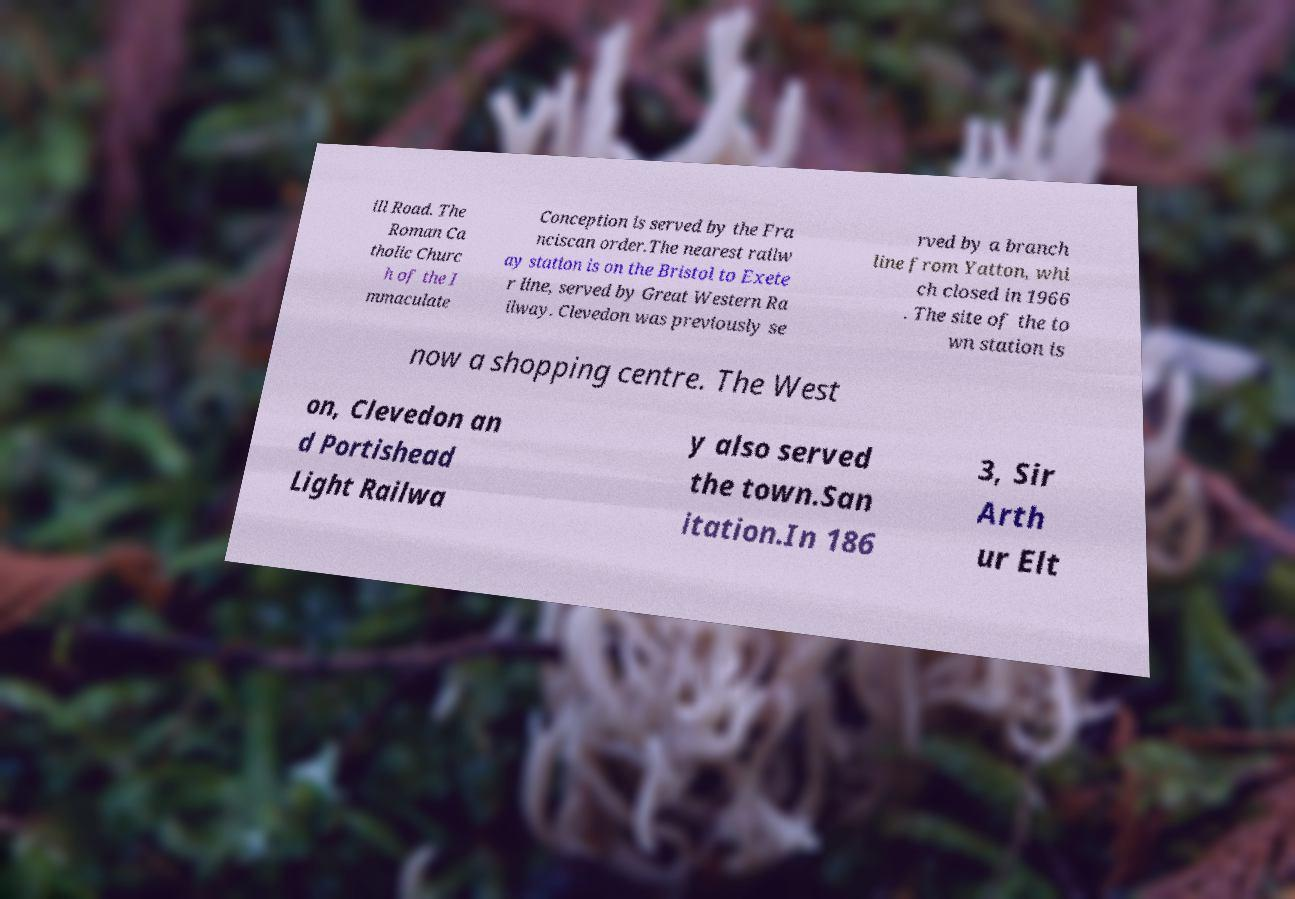Can you accurately transcribe the text from the provided image for me? ill Road. The Roman Ca tholic Churc h of the I mmaculate Conception is served by the Fra nciscan order.The nearest railw ay station is on the Bristol to Exete r line, served by Great Western Ra ilway. Clevedon was previously se rved by a branch line from Yatton, whi ch closed in 1966 . The site of the to wn station is now a shopping centre. The West on, Clevedon an d Portishead Light Railwa y also served the town.San itation.In 186 3, Sir Arth ur Elt 